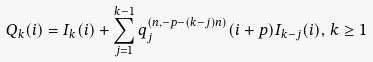Convert formula to latex. <formula><loc_0><loc_0><loc_500><loc_500>Q _ { k } ( i ) = I _ { k } ( i ) + \sum _ { j = 1 } ^ { k - 1 } q _ { j } ^ { ( n , - p - ( k - j ) n ) } ( i + p ) I _ { k - j } ( i ) , \, k \geq 1</formula> 